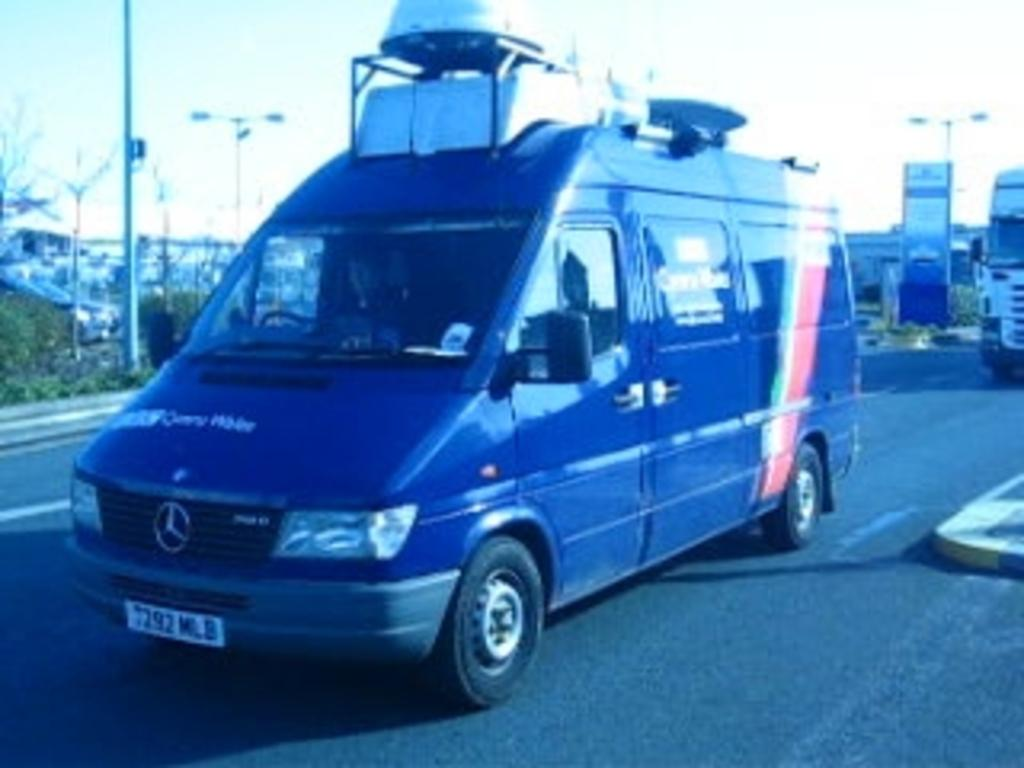<image>
Render a clear and concise summary of the photo. A Mercedes van has a license plate on it that says MLB 